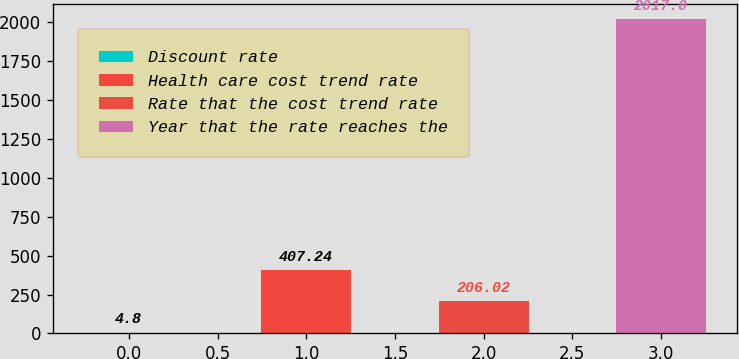<chart> <loc_0><loc_0><loc_500><loc_500><bar_chart><fcel>Discount rate<fcel>Health care cost trend rate<fcel>Rate that the cost trend rate<fcel>Year that the rate reaches the<nl><fcel>4.8<fcel>407.24<fcel>206.02<fcel>2017<nl></chart> 